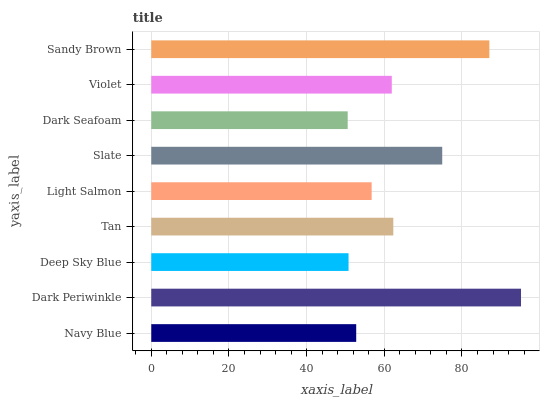Is Dark Seafoam the minimum?
Answer yes or no. Yes. Is Dark Periwinkle the maximum?
Answer yes or no. Yes. Is Deep Sky Blue the minimum?
Answer yes or no. No. Is Deep Sky Blue the maximum?
Answer yes or no. No. Is Dark Periwinkle greater than Deep Sky Blue?
Answer yes or no. Yes. Is Deep Sky Blue less than Dark Periwinkle?
Answer yes or no. Yes. Is Deep Sky Blue greater than Dark Periwinkle?
Answer yes or no. No. Is Dark Periwinkle less than Deep Sky Blue?
Answer yes or no. No. Is Violet the high median?
Answer yes or no. Yes. Is Violet the low median?
Answer yes or no. Yes. Is Dark Seafoam the high median?
Answer yes or no. No. Is Dark Seafoam the low median?
Answer yes or no. No. 